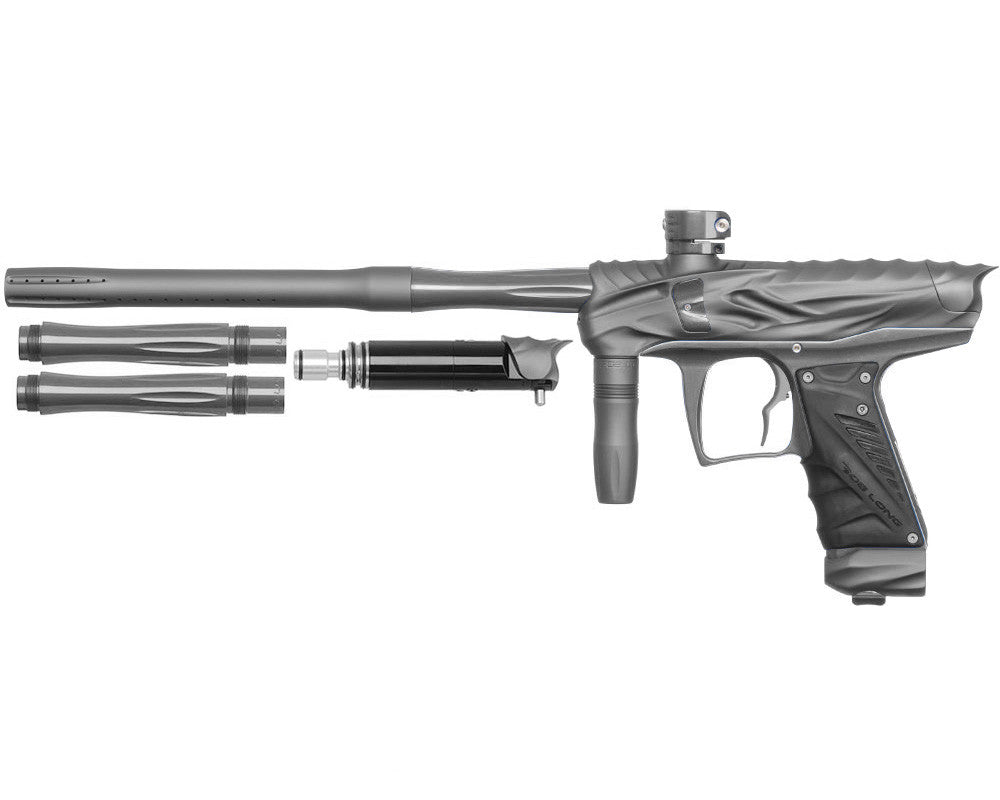How does the design of the grip enhance the handling of this paintball gun? The design of the grip on this paintball gun is ergonomically tailored to fit comfortably in the hand, ensuring a firm and stable hold even during rapid movements. This enhances handling by reducing fatigue and improving control, crucial for maintaining accuracy over extended periods of competitive play. 